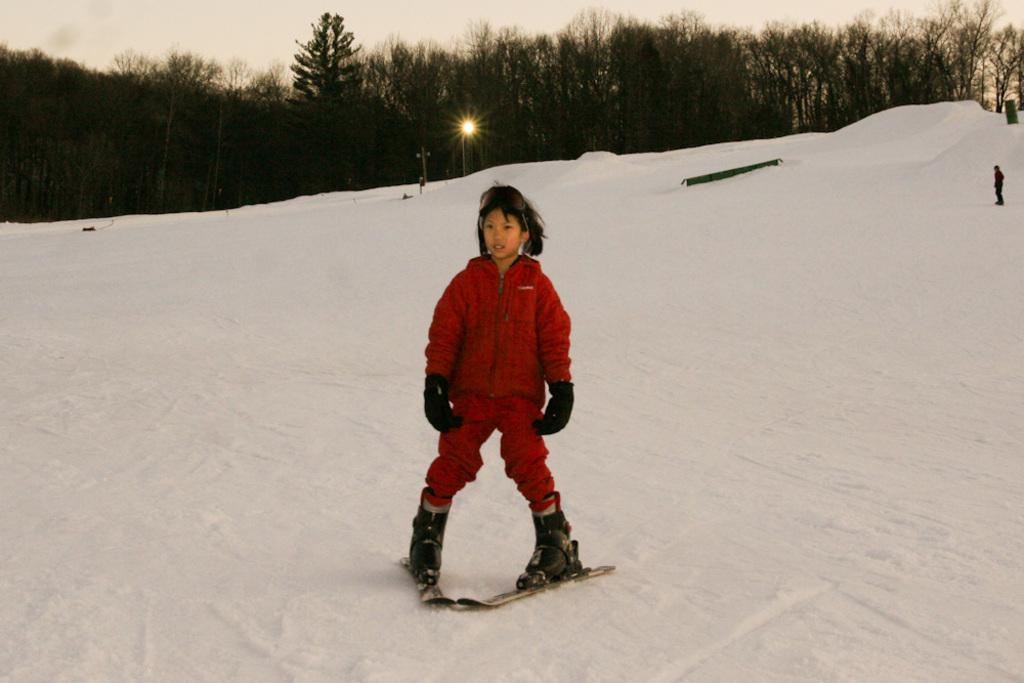Who is the main subject in the image? There is a boy in the image. What is the boy wearing? The boy is wearing a red jacket and ski shoes. What type of terrain is the boy standing on? The boy is standing on snow. What can be seen in the background of the image? There are trees visible in the background of the image. What word is the boy trying to spell in the image? There is no indication in the image that the boy is trying to spell a word, as he is wearing ski shoes and standing on snow, suggesting a winter activity. 